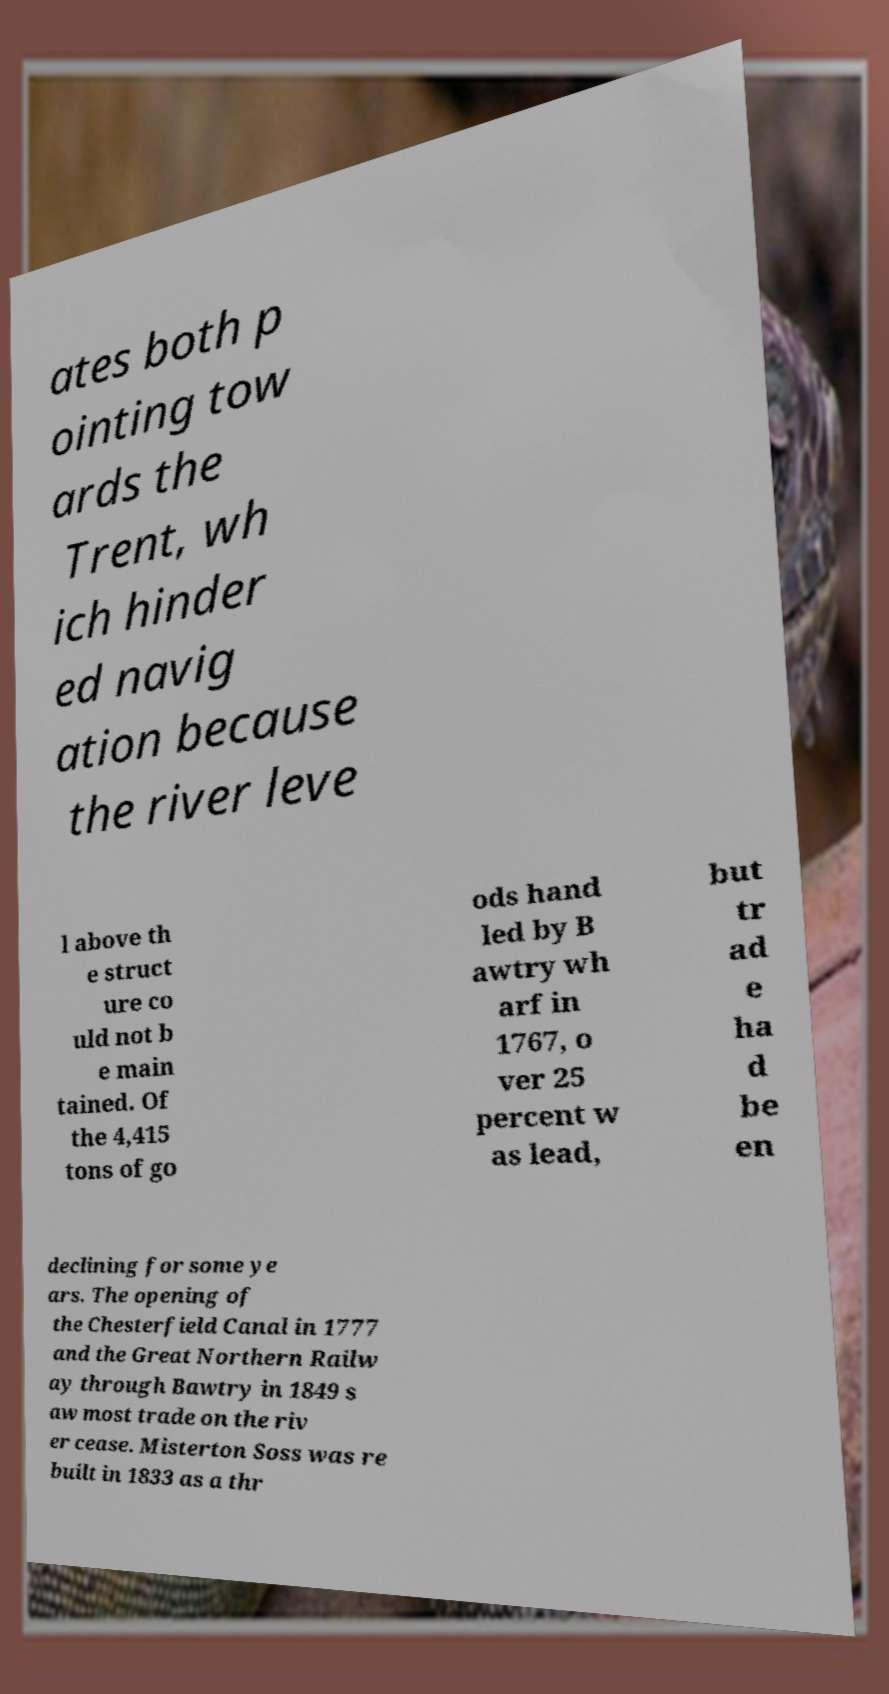Could you assist in decoding the text presented in this image and type it out clearly? ates both p ointing tow ards the Trent, wh ich hinder ed navig ation because the river leve l above th e struct ure co uld not b e main tained. Of the 4,415 tons of go ods hand led by B awtry wh arf in 1767, o ver 25 percent w as lead, but tr ad e ha d be en declining for some ye ars. The opening of the Chesterfield Canal in 1777 and the Great Northern Railw ay through Bawtry in 1849 s aw most trade on the riv er cease. Misterton Soss was re built in 1833 as a thr 